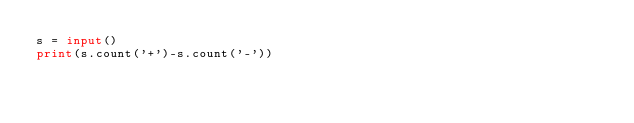Convert code to text. <code><loc_0><loc_0><loc_500><loc_500><_Python_>s = input()
print(s.count('+')-s.count('-'))</code> 